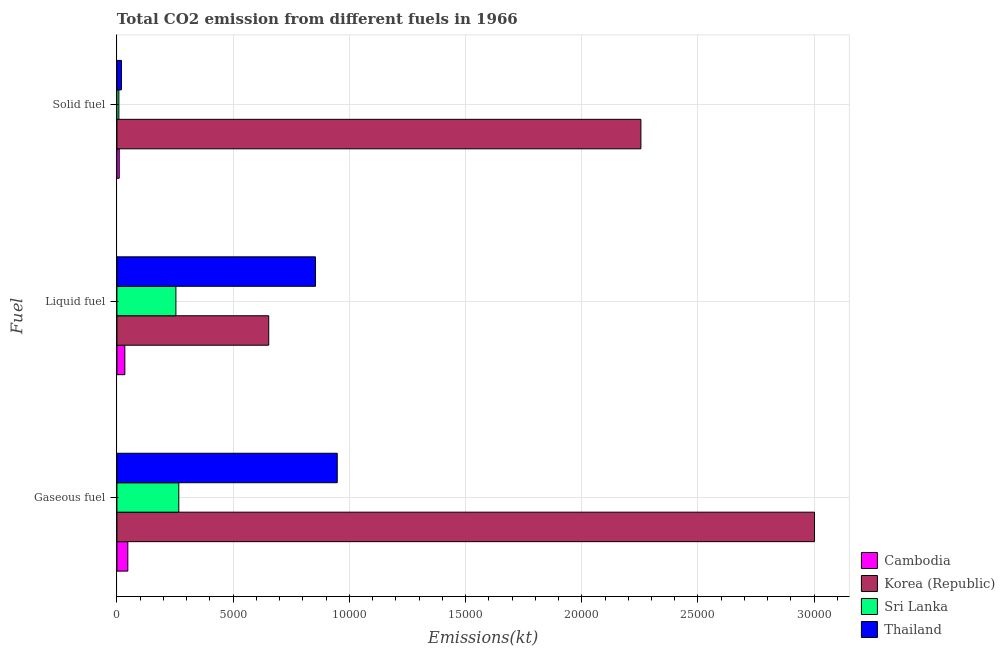How many different coloured bars are there?
Ensure brevity in your answer.  4. How many groups of bars are there?
Make the answer very short. 3. Are the number of bars per tick equal to the number of legend labels?
Offer a very short reply. Yes. Are the number of bars on each tick of the Y-axis equal?
Your response must be concise. Yes. How many bars are there on the 1st tick from the bottom?
Keep it short and to the point. 4. What is the label of the 2nd group of bars from the top?
Ensure brevity in your answer.  Liquid fuel. What is the amount of co2 emissions from solid fuel in Cambodia?
Offer a terse response. 99.01. Across all countries, what is the maximum amount of co2 emissions from solid fuel?
Make the answer very short. 2.25e+04. Across all countries, what is the minimum amount of co2 emissions from gaseous fuel?
Keep it short and to the point. 469.38. In which country was the amount of co2 emissions from liquid fuel minimum?
Your response must be concise. Cambodia. What is the total amount of co2 emissions from solid fuel in the graph?
Your answer should be very brief. 2.29e+04. What is the difference between the amount of co2 emissions from gaseous fuel in Cambodia and that in Thailand?
Keep it short and to the point. -9009.82. What is the difference between the amount of co2 emissions from gaseous fuel in Sri Lanka and the amount of co2 emissions from liquid fuel in Cambodia?
Give a very brief answer. 2321.21. What is the average amount of co2 emissions from gaseous fuel per country?
Provide a short and direct response. 1.07e+04. What is the difference between the amount of co2 emissions from gaseous fuel and amount of co2 emissions from solid fuel in Cambodia?
Keep it short and to the point. 370.37. What is the ratio of the amount of co2 emissions from solid fuel in Korea (Republic) to that in Cambodia?
Offer a very short reply. 227.7. What is the difference between the highest and the second highest amount of co2 emissions from liquid fuel?
Your answer should be compact. 2013.18. What is the difference between the highest and the lowest amount of co2 emissions from gaseous fuel?
Provide a succinct answer. 2.95e+04. In how many countries, is the amount of co2 emissions from gaseous fuel greater than the average amount of co2 emissions from gaseous fuel taken over all countries?
Offer a very short reply. 1. Is the sum of the amount of co2 emissions from liquid fuel in Thailand and Korea (Republic) greater than the maximum amount of co2 emissions from gaseous fuel across all countries?
Provide a succinct answer. No. What does the 1st bar from the top in Liquid fuel represents?
Your response must be concise. Thailand. What does the 1st bar from the bottom in Liquid fuel represents?
Make the answer very short. Cambodia. Is it the case that in every country, the sum of the amount of co2 emissions from gaseous fuel and amount of co2 emissions from liquid fuel is greater than the amount of co2 emissions from solid fuel?
Provide a short and direct response. Yes. Are the values on the major ticks of X-axis written in scientific E-notation?
Make the answer very short. No. Does the graph contain any zero values?
Offer a very short reply. No. Does the graph contain grids?
Make the answer very short. Yes. Where does the legend appear in the graph?
Your answer should be compact. Bottom right. How many legend labels are there?
Your answer should be very brief. 4. What is the title of the graph?
Your answer should be compact. Total CO2 emission from different fuels in 1966. What is the label or title of the X-axis?
Offer a terse response. Emissions(kt). What is the label or title of the Y-axis?
Provide a short and direct response. Fuel. What is the Emissions(kt) in Cambodia in Gaseous fuel?
Ensure brevity in your answer.  469.38. What is the Emissions(kt) in Korea (Republic) in Gaseous fuel?
Make the answer very short. 3.00e+04. What is the Emissions(kt) of Sri Lanka in Gaseous fuel?
Your answer should be compact. 2662.24. What is the Emissions(kt) of Thailand in Gaseous fuel?
Give a very brief answer. 9479.19. What is the Emissions(kt) of Cambodia in Liquid fuel?
Your answer should be very brief. 341.03. What is the Emissions(kt) in Korea (Republic) in Liquid fuel?
Keep it short and to the point. 6530.93. What is the Emissions(kt) in Sri Lanka in Liquid fuel?
Give a very brief answer. 2537.56. What is the Emissions(kt) of Thailand in Liquid fuel?
Your answer should be very brief. 8544.11. What is the Emissions(kt) of Cambodia in Solid fuel?
Your answer should be very brief. 99.01. What is the Emissions(kt) in Korea (Republic) in Solid fuel?
Your answer should be very brief. 2.25e+04. What is the Emissions(kt) of Sri Lanka in Solid fuel?
Give a very brief answer. 84.34. What is the Emissions(kt) of Thailand in Solid fuel?
Keep it short and to the point. 194.35. Across all Fuel, what is the maximum Emissions(kt) in Cambodia?
Make the answer very short. 469.38. Across all Fuel, what is the maximum Emissions(kt) in Korea (Republic)?
Offer a terse response. 3.00e+04. Across all Fuel, what is the maximum Emissions(kt) in Sri Lanka?
Ensure brevity in your answer.  2662.24. Across all Fuel, what is the maximum Emissions(kt) of Thailand?
Your response must be concise. 9479.19. Across all Fuel, what is the minimum Emissions(kt) in Cambodia?
Make the answer very short. 99.01. Across all Fuel, what is the minimum Emissions(kt) in Korea (Republic)?
Your response must be concise. 6530.93. Across all Fuel, what is the minimum Emissions(kt) in Sri Lanka?
Offer a very short reply. 84.34. Across all Fuel, what is the minimum Emissions(kt) of Thailand?
Your answer should be very brief. 194.35. What is the total Emissions(kt) in Cambodia in the graph?
Give a very brief answer. 909.42. What is the total Emissions(kt) in Korea (Republic) in the graph?
Provide a succinct answer. 5.91e+04. What is the total Emissions(kt) of Sri Lanka in the graph?
Offer a very short reply. 5284.15. What is the total Emissions(kt) of Thailand in the graph?
Give a very brief answer. 1.82e+04. What is the difference between the Emissions(kt) in Cambodia in Gaseous fuel and that in Liquid fuel?
Your response must be concise. 128.34. What is the difference between the Emissions(kt) of Korea (Republic) in Gaseous fuel and that in Liquid fuel?
Provide a succinct answer. 2.35e+04. What is the difference between the Emissions(kt) in Sri Lanka in Gaseous fuel and that in Liquid fuel?
Offer a terse response. 124.68. What is the difference between the Emissions(kt) in Thailand in Gaseous fuel and that in Liquid fuel?
Provide a short and direct response. 935.09. What is the difference between the Emissions(kt) in Cambodia in Gaseous fuel and that in Solid fuel?
Provide a succinct answer. 370.37. What is the difference between the Emissions(kt) of Korea (Republic) in Gaseous fuel and that in Solid fuel?
Ensure brevity in your answer.  7469.68. What is the difference between the Emissions(kt) of Sri Lanka in Gaseous fuel and that in Solid fuel?
Your response must be concise. 2577.9. What is the difference between the Emissions(kt) in Thailand in Gaseous fuel and that in Solid fuel?
Ensure brevity in your answer.  9284.84. What is the difference between the Emissions(kt) of Cambodia in Liquid fuel and that in Solid fuel?
Your answer should be very brief. 242.02. What is the difference between the Emissions(kt) in Korea (Republic) in Liquid fuel and that in Solid fuel?
Provide a succinct answer. -1.60e+04. What is the difference between the Emissions(kt) of Sri Lanka in Liquid fuel and that in Solid fuel?
Your answer should be compact. 2453.22. What is the difference between the Emissions(kt) of Thailand in Liquid fuel and that in Solid fuel?
Your answer should be very brief. 8349.76. What is the difference between the Emissions(kt) of Cambodia in Gaseous fuel and the Emissions(kt) of Korea (Republic) in Liquid fuel?
Ensure brevity in your answer.  -6061.55. What is the difference between the Emissions(kt) in Cambodia in Gaseous fuel and the Emissions(kt) in Sri Lanka in Liquid fuel?
Offer a very short reply. -2068.19. What is the difference between the Emissions(kt) of Cambodia in Gaseous fuel and the Emissions(kt) of Thailand in Liquid fuel?
Ensure brevity in your answer.  -8074.73. What is the difference between the Emissions(kt) in Korea (Republic) in Gaseous fuel and the Emissions(kt) in Sri Lanka in Liquid fuel?
Offer a very short reply. 2.75e+04. What is the difference between the Emissions(kt) of Korea (Republic) in Gaseous fuel and the Emissions(kt) of Thailand in Liquid fuel?
Make the answer very short. 2.15e+04. What is the difference between the Emissions(kt) of Sri Lanka in Gaseous fuel and the Emissions(kt) of Thailand in Liquid fuel?
Give a very brief answer. -5881.87. What is the difference between the Emissions(kt) of Cambodia in Gaseous fuel and the Emissions(kt) of Korea (Republic) in Solid fuel?
Offer a very short reply. -2.21e+04. What is the difference between the Emissions(kt) in Cambodia in Gaseous fuel and the Emissions(kt) in Sri Lanka in Solid fuel?
Provide a succinct answer. 385.04. What is the difference between the Emissions(kt) of Cambodia in Gaseous fuel and the Emissions(kt) of Thailand in Solid fuel?
Give a very brief answer. 275.02. What is the difference between the Emissions(kt) in Korea (Republic) in Gaseous fuel and the Emissions(kt) in Sri Lanka in Solid fuel?
Give a very brief answer. 2.99e+04. What is the difference between the Emissions(kt) in Korea (Republic) in Gaseous fuel and the Emissions(kt) in Thailand in Solid fuel?
Your answer should be very brief. 2.98e+04. What is the difference between the Emissions(kt) in Sri Lanka in Gaseous fuel and the Emissions(kt) in Thailand in Solid fuel?
Your response must be concise. 2467.89. What is the difference between the Emissions(kt) of Cambodia in Liquid fuel and the Emissions(kt) of Korea (Republic) in Solid fuel?
Provide a succinct answer. -2.22e+04. What is the difference between the Emissions(kt) in Cambodia in Liquid fuel and the Emissions(kt) in Sri Lanka in Solid fuel?
Offer a terse response. 256.69. What is the difference between the Emissions(kt) of Cambodia in Liquid fuel and the Emissions(kt) of Thailand in Solid fuel?
Your answer should be compact. 146.68. What is the difference between the Emissions(kt) of Korea (Republic) in Liquid fuel and the Emissions(kt) of Sri Lanka in Solid fuel?
Ensure brevity in your answer.  6446.59. What is the difference between the Emissions(kt) in Korea (Republic) in Liquid fuel and the Emissions(kt) in Thailand in Solid fuel?
Make the answer very short. 6336.58. What is the difference between the Emissions(kt) in Sri Lanka in Liquid fuel and the Emissions(kt) in Thailand in Solid fuel?
Give a very brief answer. 2343.21. What is the average Emissions(kt) of Cambodia per Fuel?
Provide a succinct answer. 303.14. What is the average Emissions(kt) in Korea (Republic) per Fuel?
Give a very brief answer. 1.97e+04. What is the average Emissions(kt) of Sri Lanka per Fuel?
Offer a terse response. 1761.38. What is the average Emissions(kt) of Thailand per Fuel?
Your response must be concise. 6072.55. What is the difference between the Emissions(kt) in Cambodia and Emissions(kt) in Korea (Republic) in Gaseous fuel?
Keep it short and to the point. -2.95e+04. What is the difference between the Emissions(kt) in Cambodia and Emissions(kt) in Sri Lanka in Gaseous fuel?
Your answer should be very brief. -2192.87. What is the difference between the Emissions(kt) of Cambodia and Emissions(kt) of Thailand in Gaseous fuel?
Make the answer very short. -9009.82. What is the difference between the Emissions(kt) in Korea (Republic) and Emissions(kt) in Sri Lanka in Gaseous fuel?
Provide a succinct answer. 2.74e+04. What is the difference between the Emissions(kt) of Korea (Republic) and Emissions(kt) of Thailand in Gaseous fuel?
Give a very brief answer. 2.05e+04. What is the difference between the Emissions(kt) in Sri Lanka and Emissions(kt) in Thailand in Gaseous fuel?
Your response must be concise. -6816.95. What is the difference between the Emissions(kt) of Cambodia and Emissions(kt) of Korea (Republic) in Liquid fuel?
Make the answer very short. -6189.9. What is the difference between the Emissions(kt) in Cambodia and Emissions(kt) in Sri Lanka in Liquid fuel?
Make the answer very short. -2196.53. What is the difference between the Emissions(kt) in Cambodia and Emissions(kt) in Thailand in Liquid fuel?
Your answer should be very brief. -8203.08. What is the difference between the Emissions(kt) in Korea (Republic) and Emissions(kt) in Sri Lanka in Liquid fuel?
Your response must be concise. 3993.36. What is the difference between the Emissions(kt) of Korea (Republic) and Emissions(kt) of Thailand in Liquid fuel?
Offer a terse response. -2013.18. What is the difference between the Emissions(kt) of Sri Lanka and Emissions(kt) of Thailand in Liquid fuel?
Make the answer very short. -6006.55. What is the difference between the Emissions(kt) in Cambodia and Emissions(kt) in Korea (Republic) in Solid fuel?
Offer a terse response. -2.24e+04. What is the difference between the Emissions(kt) of Cambodia and Emissions(kt) of Sri Lanka in Solid fuel?
Your answer should be very brief. 14.67. What is the difference between the Emissions(kt) of Cambodia and Emissions(kt) of Thailand in Solid fuel?
Ensure brevity in your answer.  -95.34. What is the difference between the Emissions(kt) in Korea (Republic) and Emissions(kt) in Sri Lanka in Solid fuel?
Offer a very short reply. 2.25e+04. What is the difference between the Emissions(kt) in Korea (Republic) and Emissions(kt) in Thailand in Solid fuel?
Offer a very short reply. 2.24e+04. What is the difference between the Emissions(kt) in Sri Lanka and Emissions(kt) in Thailand in Solid fuel?
Your answer should be very brief. -110.01. What is the ratio of the Emissions(kt) in Cambodia in Gaseous fuel to that in Liquid fuel?
Keep it short and to the point. 1.38. What is the ratio of the Emissions(kt) of Korea (Republic) in Gaseous fuel to that in Liquid fuel?
Provide a succinct answer. 4.6. What is the ratio of the Emissions(kt) of Sri Lanka in Gaseous fuel to that in Liquid fuel?
Provide a succinct answer. 1.05. What is the ratio of the Emissions(kt) in Thailand in Gaseous fuel to that in Liquid fuel?
Your answer should be compact. 1.11. What is the ratio of the Emissions(kt) of Cambodia in Gaseous fuel to that in Solid fuel?
Keep it short and to the point. 4.74. What is the ratio of the Emissions(kt) of Korea (Republic) in Gaseous fuel to that in Solid fuel?
Your response must be concise. 1.33. What is the ratio of the Emissions(kt) in Sri Lanka in Gaseous fuel to that in Solid fuel?
Keep it short and to the point. 31.57. What is the ratio of the Emissions(kt) in Thailand in Gaseous fuel to that in Solid fuel?
Offer a terse response. 48.77. What is the ratio of the Emissions(kt) of Cambodia in Liquid fuel to that in Solid fuel?
Your response must be concise. 3.44. What is the ratio of the Emissions(kt) in Korea (Republic) in Liquid fuel to that in Solid fuel?
Offer a terse response. 0.29. What is the ratio of the Emissions(kt) of Sri Lanka in Liquid fuel to that in Solid fuel?
Your answer should be compact. 30.09. What is the ratio of the Emissions(kt) of Thailand in Liquid fuel to that in Solid fuel?
Your answer should be compact. 43.96. What is the difference between the highest and the second highest Emissions(kt) of Cambodia?
Keep it short and to the point. 128.34. What is the difference between the highest and the second highest Emissions(kt) in Korea (Republic)?
Ensure brevity in your answer.  7469.68. What is the difference between the highest and the second highest Emissions(kt) in Sri Lanka?
Give a very brief answer. 124.68. What is the difference between the highest and the second highest Emissions(kt) in Thailand?
Offer a very short reply. 935.09. What is the difference between the highest and the lowest Emissions(kt) in Cambodia?
Give a very brief answer. 370.37. What is the difference between the highest and the lowest Emissions(kt) in Korea (Republic)?
Provide a short and direct response. 2.35e+04. What is the difference between the highest and the lowest Emissions(kt) in Sri Lanka?
Your answer should be very brief. 2577.9. What is the difference between the highest and the lowest Emissions(kt) of Thailand?
Your answer should be compact. 9284.84. 